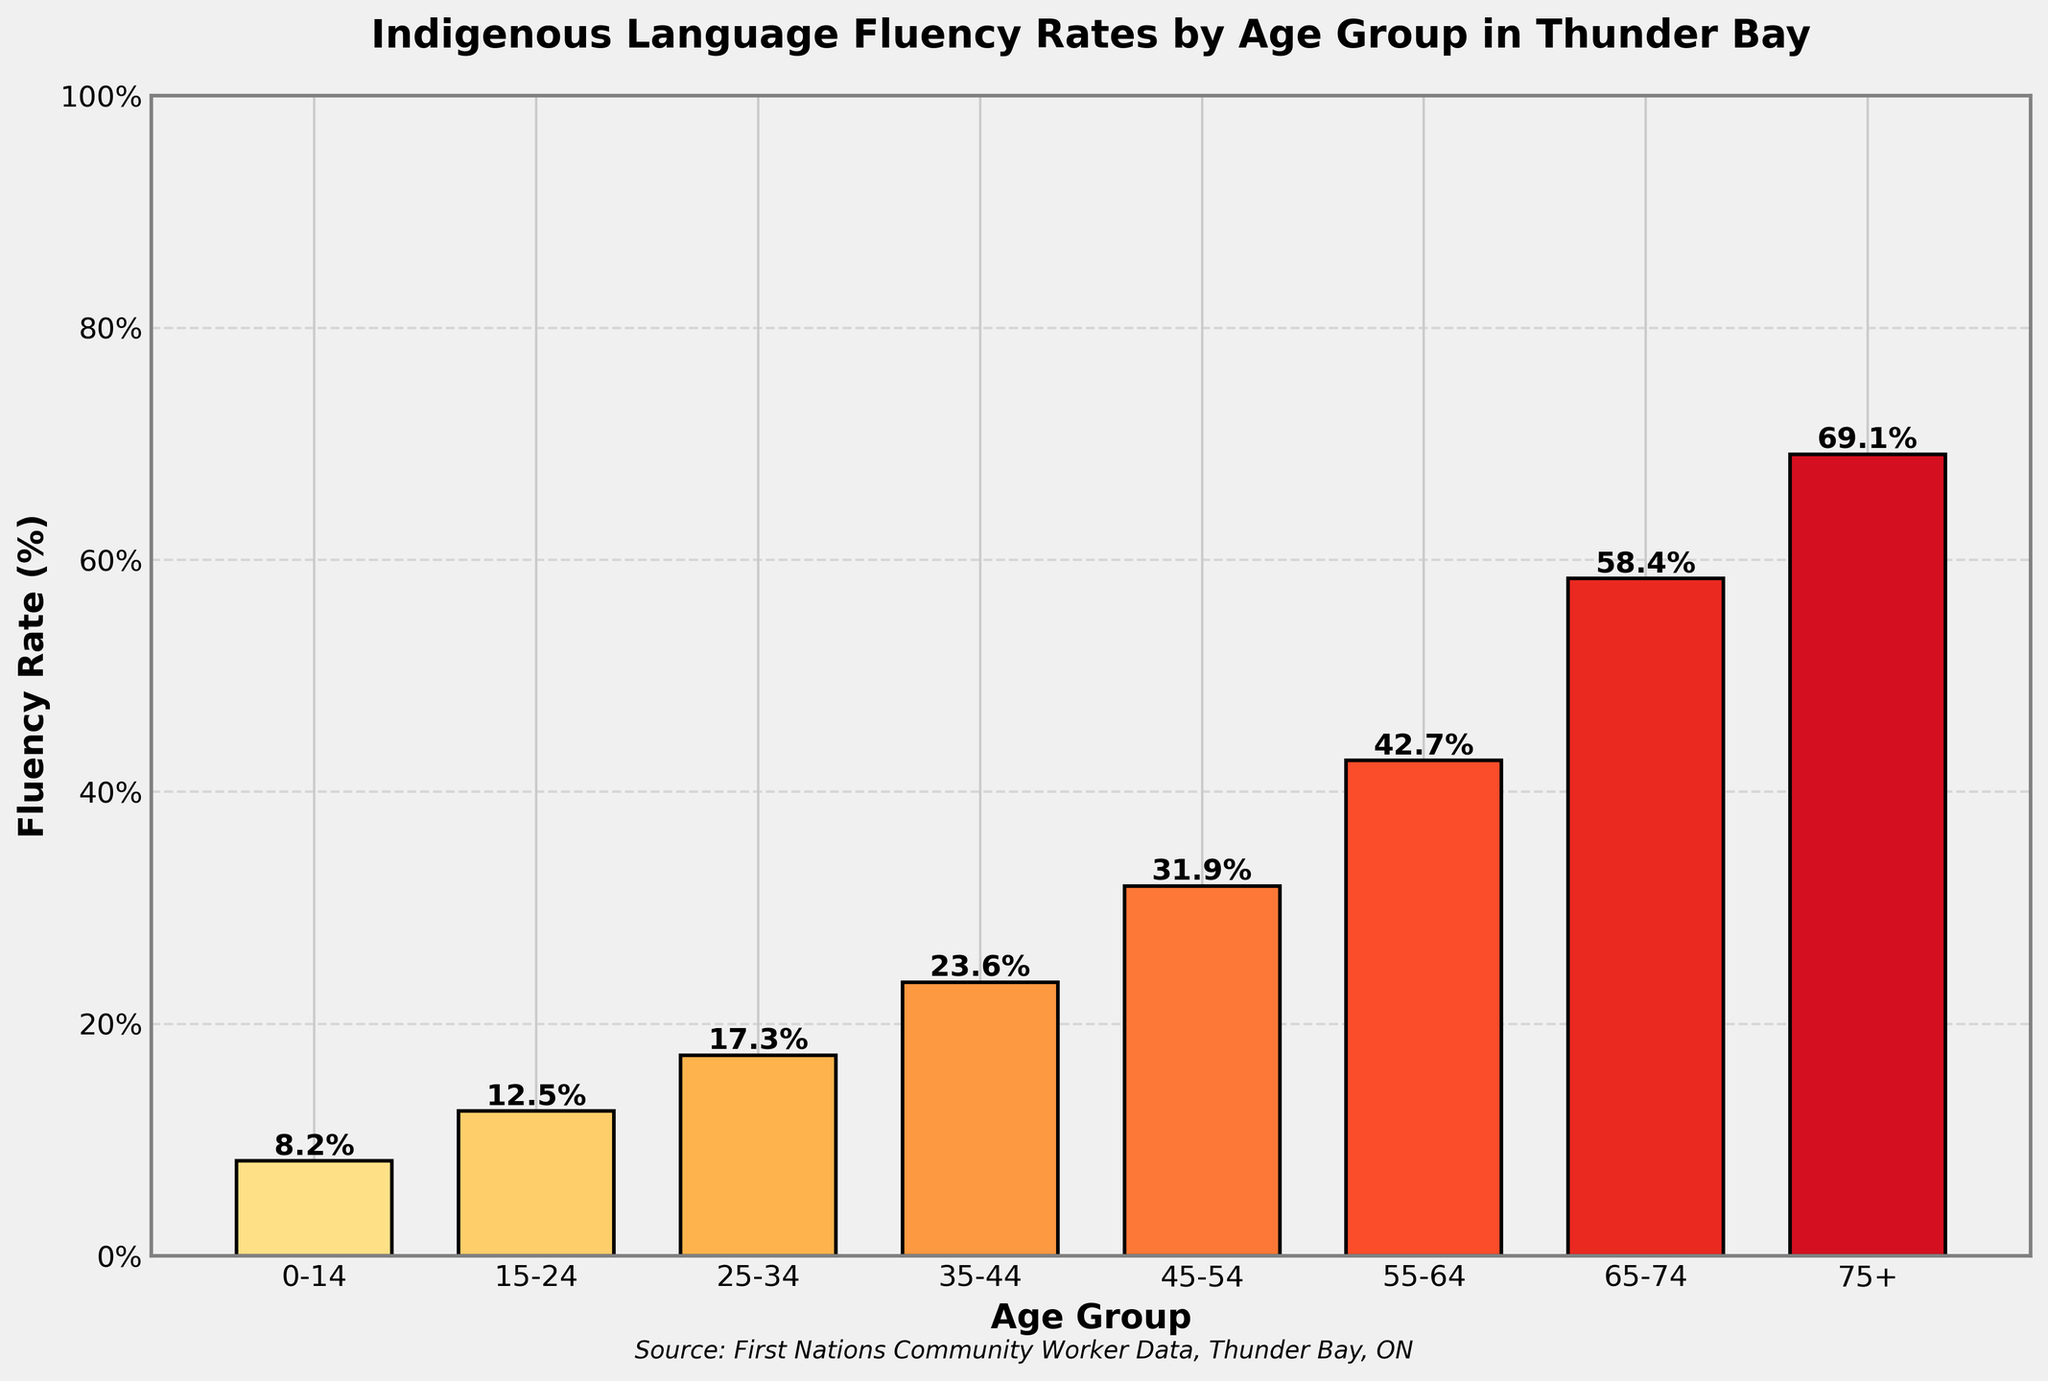What is the fluency rate for the age group 25-34? The fluency rate for this age group is stated directly in the chart as a percentage.
Answer: 17.3% Which age group has the highest fluency rate of Indigenous languages? By observing the heights of the bars and the values at the top of each bar, the highest rate is 69.1% for the age group 75+.
Answer: 75+ How does the fluency rate of the 0-14 age group compare with that of the 15-24 age group? The fluency rate for the 0-14 age group is 8.2%, and for the 15-24 age group, it is 12.5%, indicating that the fluency rate in the 15-24 group is higher.
Answer: 15-24 group has a higher rate By how much does the fluency rate increase from the 35-44 age group to the 45-54 age group? The fluency rate for the 35-44 age group is 23.6% and for the 45-54 age group is 31.9%. The difference is 31.9% - 23.6% = 8.3%.
Answer: 8.3% What is the average fluency rate of all age groups combined? The fluency rates are added together: 8.2 + 12.5 + 17.3 + 23.6 + 31.9 + 42.7 + 58.4 + 69.1 = 263.7. The average is 263.7 / 8 = 32.96%.
Answer: 32.96% Which age group has a fluency rate closest to 50%? Observing the fluency rates, the age group closest to 50% is the 65-74 group with a fluency rate of 58.4%.
Answer: 65-74 What percentage difference is there between the fluency rates of the 15-24 and 55-64 age groups? The difference is calculated by subtracting the lower rate from the higher rate: 42.7% - 12.5% = 30.2%.
Answer: 30.2% Is the fluency rate trend increasing or decreasing with age? Observing the chart, the fluency rate consistently increases with age from 0-14 to 75+.
Answer: Increasing Which bar is the second highest in the chart? The bar representing the age group 65-74 with a fluency rate of 58.4% is the second highest, just below the 75+ group at 69.1%.
Answer: 65-74 If the fluency rate of the 35-44 age group increased by 10%, what would be the new rate? The current fluency rate is 23.6%. Increasing this by 10% translates to 23.6% + 10% = 33.6%.
Answer: 33.6% 